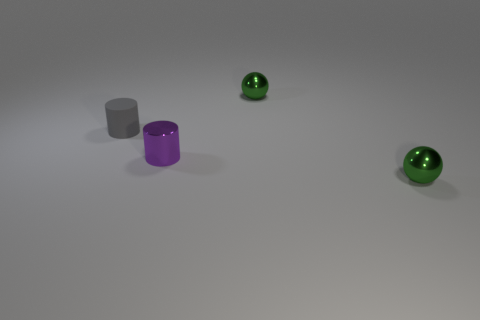Subtract all red cylinders. Subtract all cyan balls. How many cylinders are left? 2 Add 2 shiny objects. How many objects exist? 6 Subtract 0 blue cylinders. How many objects are left? 4 Subtract all tiny purple things. Subtract all tiny purple metal things. How many objects are left? 2 Add 4 metallic things. How many metallic things are left? 7 Add 1 purple cylinders. How many purple cylinders exist? 2 